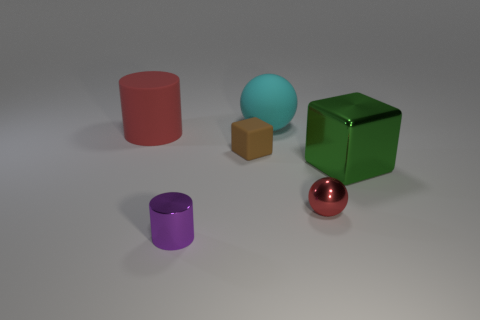Do the sphere that is in front of the green cube and the large matte cylinder have the same color?
Your answer should be compact. Yes. The other object that is the same shape as the cyan matte thing is what size?
Provide a short and direct response. Small. What is the color of the metallic object that is the same shape as the big red matte object?
Your answer should be very brief. Purple. What color is the large rubber thing that is right of the cylinder that is to the right of the large red rubber object?
Offer a very short reply. Cyan. How many things are either big rubber objects on the right side of the metal cylinder or matte things right of the brown rubber thing?
Provide a succinct answer. 1. What is the color of the big metallic cube?
Ensure brevity in your answer.  Green. What number of small brown things have the same material as the small red thing?
Keep it short and to the point. 0. Is the number of big green metallic objects greater than the number of large brown matte cylinders?
Your response must be concise. Yes. What number of small brown matte things are on the right side of the ball that is behind the brown rubber object?
Your response must be concise. 0. What number of objects are things behind the purple cylinder or tiny red metallic cylinders?
Keep it short and to the point. 5. 